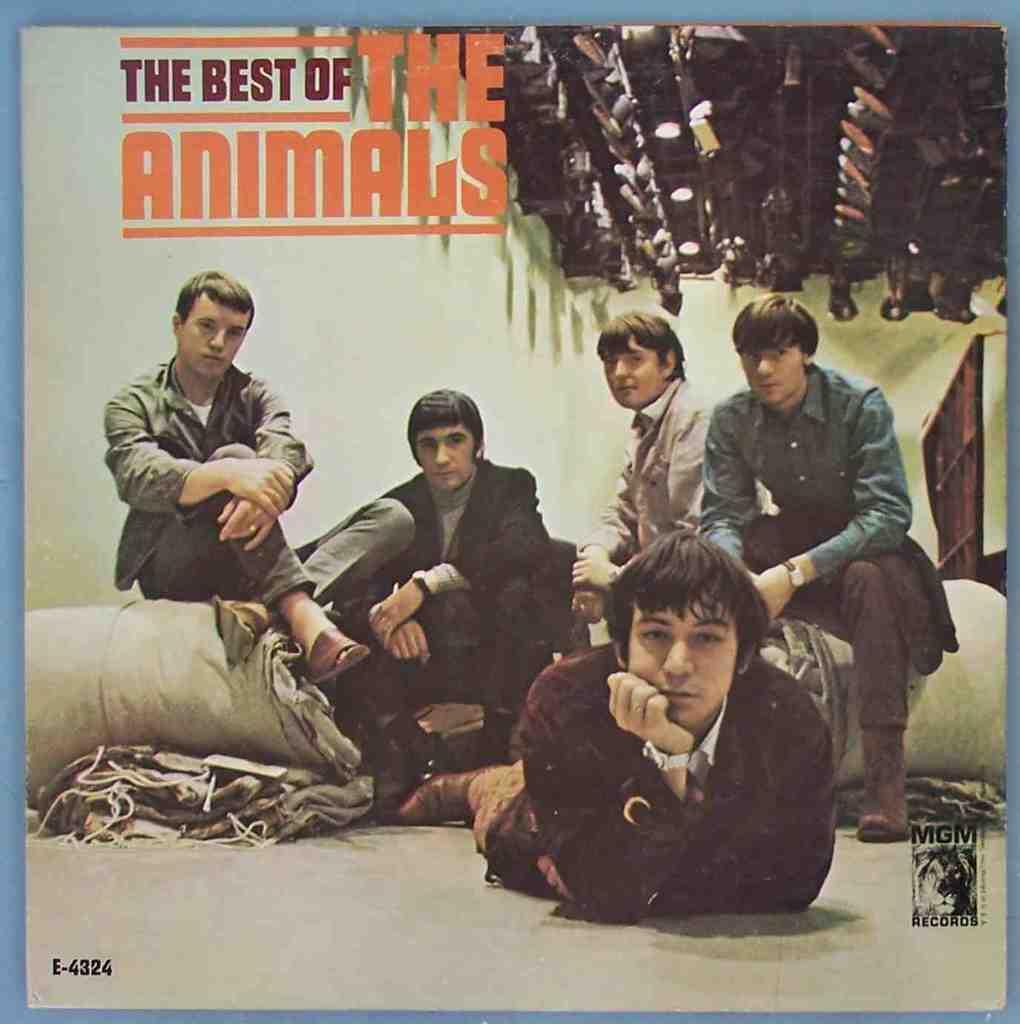Please provide a concise description of this image. In this image, we can see a poster with some images and text. 